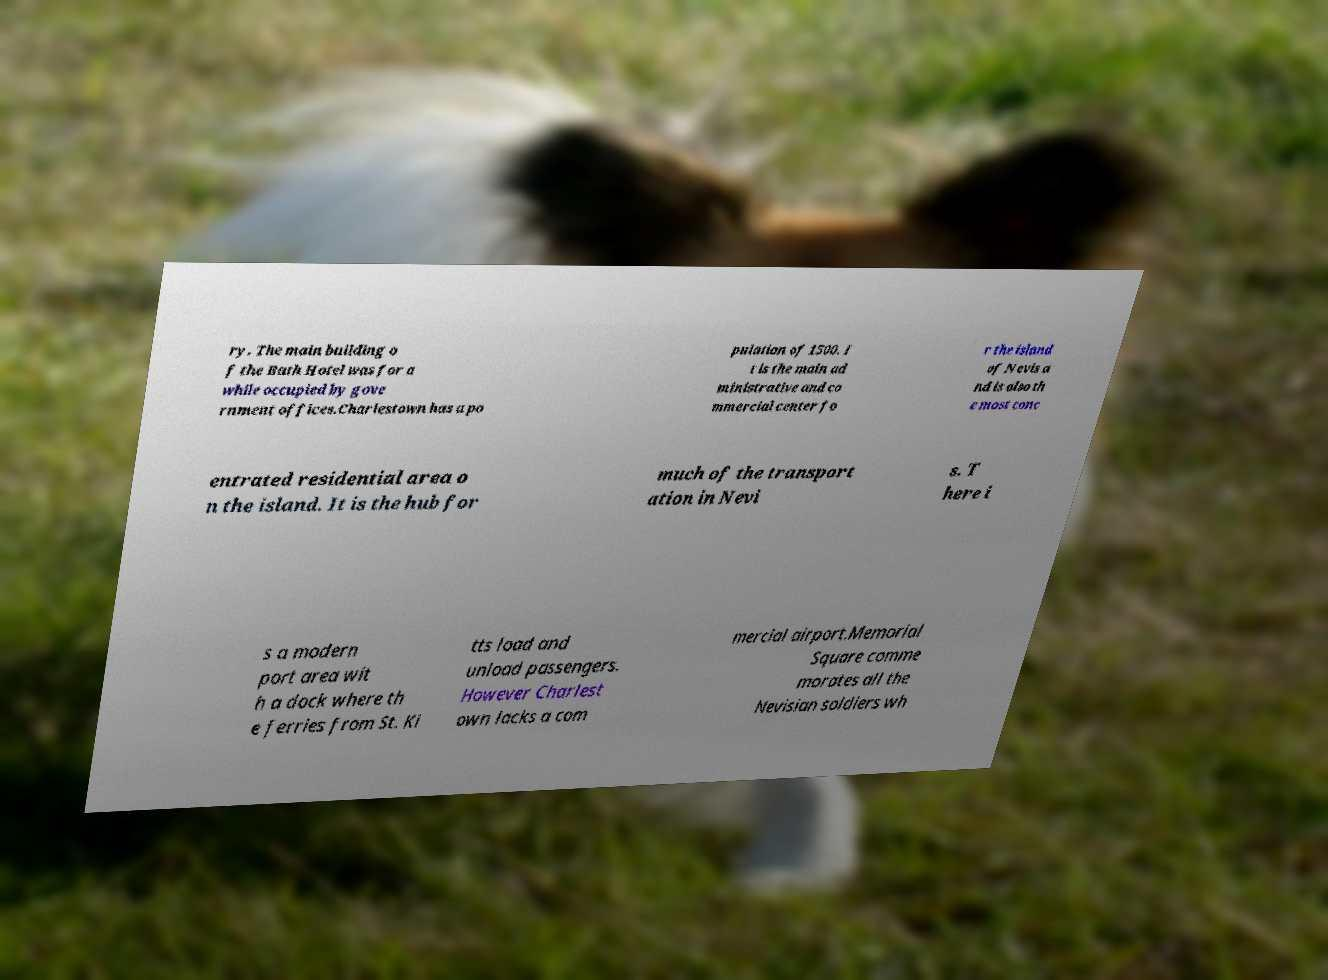Can you read and provide the text displayed in the image?This photo seems to have some interesting text. Can you extract and type it out for me? ry. The main building o f the Bath Hotel was for a while occupied by gove rnment offices.Charlestown has a po pulation of 1500. I t is the main ad ministrative and co mmercial center fo r the island of Nevis a nd is also th e most conc entrated residential area o n the island. It is the hub for much of the transport ation in Nevi s. T here i s a modern port area wit h a dock where th e ferries from St. Ki tts load and unload passengers. However Charlest own lacks a com mercial airport.Memorial Square comme morates all the Nevisian soldiers wh 